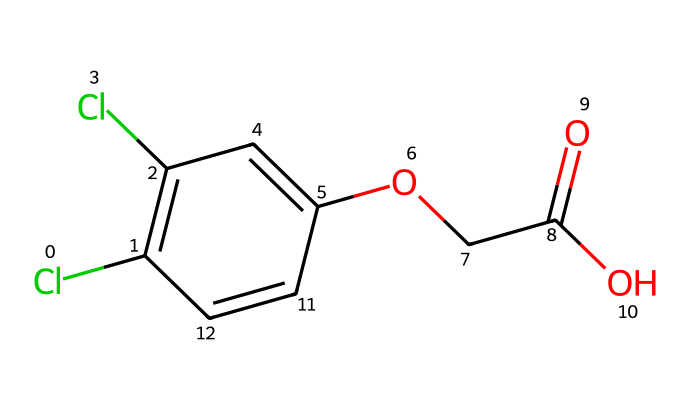What is the molecular formula of 2,4-D? To determine the molecular formula, we count the number of each type of atom present in the structure. The chemical has 8 carbon (C) atoms, 6 hydrogen (H) atoms, 2 chlorine (Cl) atoms, and 4 oxygen (O) atoms. Combining these gives the molecular formula C8H6Cl2O4.
Answer: C8H6Cl2O4 How many rings are present in the structure? Looking at the chemical structure, we can identify the presence of a benzene ring which is comprised of 6 carbon atoms. Thus, there is one ring present in this structure.
Answer: 1 What functional group is present at the end of the molecule? Analyzing the structure, we see a carboxylic acid group (-COOH) which is characterized by a carbon atom double-bonded to an oxygen atom and single-bonded to a hydroxyl group (OH). This indicates the presence of the carboxylic acid functional group.
Answer: Carboxylic acid How many chlorine atoms are in 2,4-D? The structure reveals the presence of two chlorine (Cl) atoms attached to the benzene ring, which can be counted directly from the diagram.
Answer: 2 What is the primary use of 2,4-D? Recognizing the properties of 2,4-D as a herbicide, it is primarily utilized for controlling broadleaf weeds in various settings including agricultural areas and stadium maintenance.
Answer: Herbicide What type of herbicide is 2,4-D classified as? 2,4-D is classified as a synthetic auxin, which is a type of herbicide that mimics natural plant hormones and disrupts normal plant growth patterns, particularly in broadleaf plants.
Answer: Synthetic auxin 